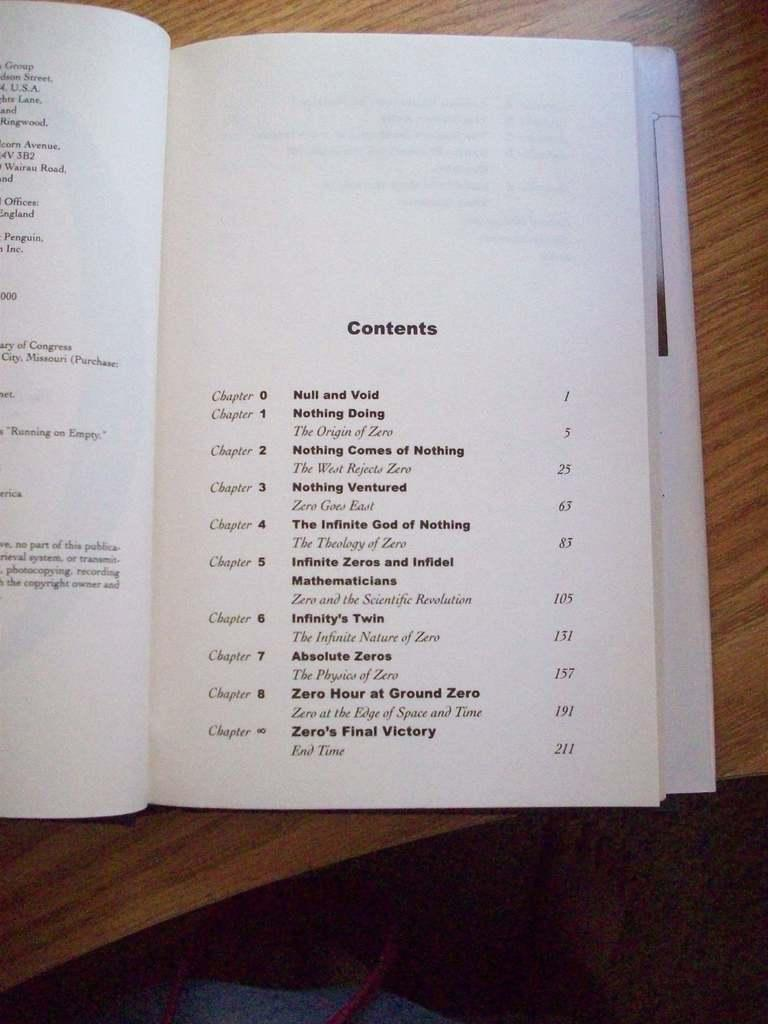<image>
Write a terse but informative summary of the picture. A book is opened to the contents page. 